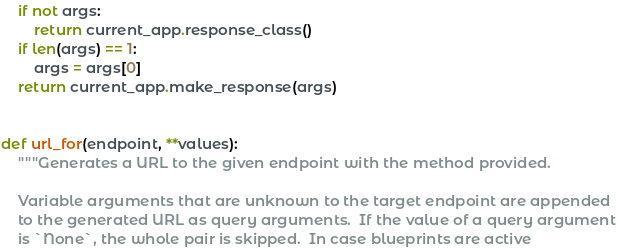Convert code to text. <code><loc_0><loc_0><loc_500><loc_500><_Python_>    if not args:
        return current_app.response_class()
    if len(args) == 1:
        args = args[0]
    return current_app.make_response(args)


def url_for(endpoint, **values):
    """Generates a URL to the given endpoint with the method provided.

    Variable arguments that are unknown to the target endpoint are appended
    to the generated URL as query arguments.  If the value of a query argument
    is `None`, the whole pair is skipped.  In case blueprints are active</code> 